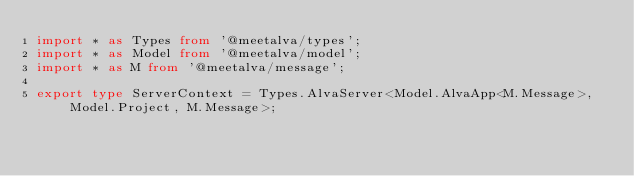Convert code to text. <code><loc_0><loc_0><loc_500><loc_500><_TypeScript_>import * as Types from '@meetalva/types';
import * as Model from '@meetalva/model';
import * as M from '@meetalva/message';

export type ServerContext = Types.AlvaServer<Model.AlvaApp<M.Message>, Model.Project, M.Message>;
</code> 